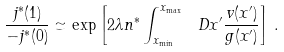Convert formula to latex. <formula><loc_0><loc_0><loc_500><loc_500>\frac { j ^ { * } ( 1 ) } { - j ^ { * } ( 0 ) } \simeq \exp \left [ 2 \lambda n ^ { * } \int _ { x _ { \min } } ^ { x _ { \max } } \ D x ^ { \prime } \frac { v ( x ^ { \prime } ) } { g ( x ^ { \prime } ) } \right ] \, .</formula> 